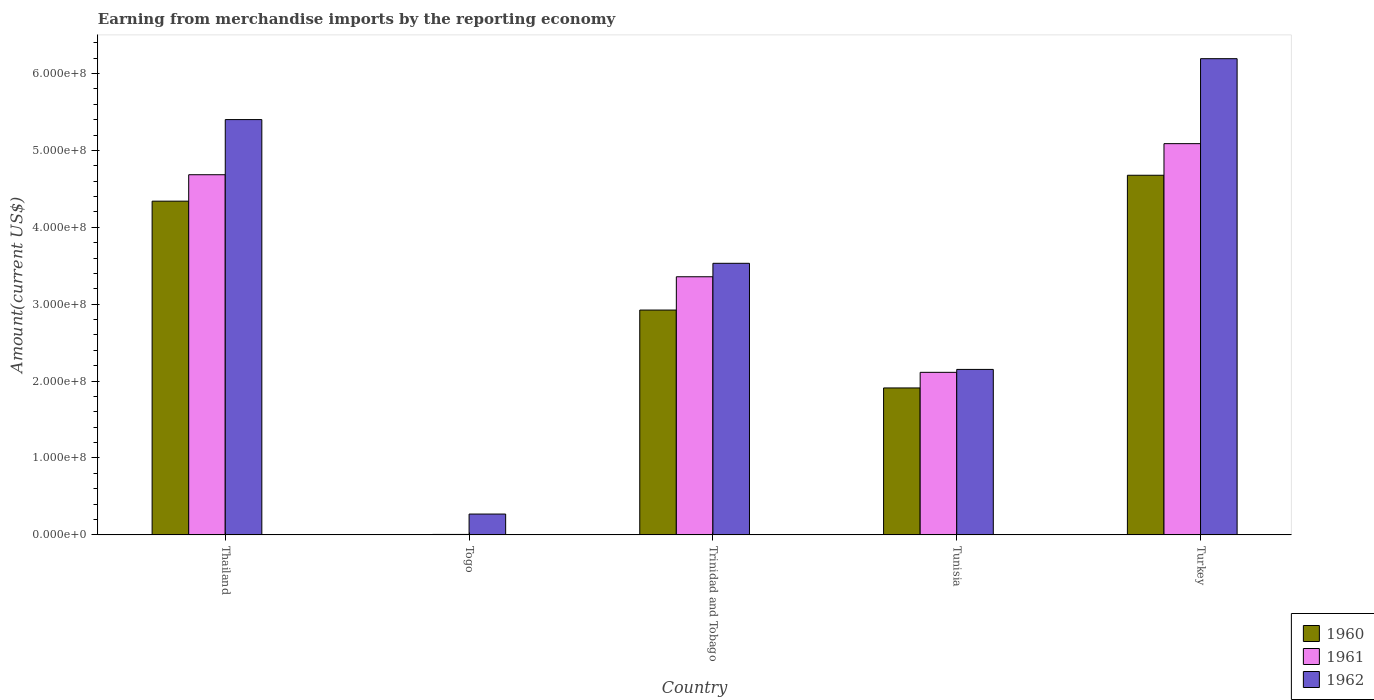How many different coloured bars are there?
Ensure brevity in your answer.  3. Are the number of bars on each tick of the X-axis equal?
Your answer should be compact. Yes. What is the label of the 1st group of bars from the left?
Your response must be concise. Thailand. In how many cases, is the number of bars for a given country not equal to the number of legend labels?
Offer a terse response. 0. What is the amount earned from merchandise imports in 1960 in Tunisia?
Your answer should be compact. 1.91e+08. Across all countries, what is the maximum amount earned from merchandise imports in 1961?
Ensure brevity in your answer.  5.09e+08. Across all countries, what is the minimum amount earned from merchandise imports in 1962?
Your answer should be compact. 2.71e+07. In which country was the amount earned from merchandise imports in 1962 minimum?
Ensure brevity in your answer.  Togo. What is the total amount earned from merchandise imports in 1961 in the graph?
Give a very brief answer. 1.52e+09. What is the difference between the amount earned from merchandise imports in 1960 in Thailand and that in Turkey?
Offer a very short reply. -3.37e+07. What is the difference between the amount earned from merchandise imports in 1960 in Togo and the amount earned from merchandise imports in 1962 in Thailand?
Your answer should be compact. -5.40e+08. What is the average amount earned from merchandise imports in 1961 per country?
Make the answer very short. 3.05e+08. What is the difference between the amount earned from merchandise imports of/in 1961 and amount earned from merchandise imports of/in 1962 in Togo?
Your response must be concise. -2.65e+07. What is the ratio of the amount earned from merchandise imports in 1962 in Thailand to that in Togo?
Provide a succinct answer. 19.93. What is the difference between the highest and the second highest amount earned from merchandise imports in 1960?
Your response must be concise. 1.75e+08. What is the difference between the highest and the lowest amount earned from merchandise imports in 1961?
Offer a very short reply. 5.08e+08. How many countries are there in the graph?
Ensure brevity in your answer.  5. What is the difference between two consecutive major ticks on the Y-axis?
Offer a very short reply. 1.00e+08. Does the graph contain any zero values?
Ensure brevity in your answer.  No. How many legend labels are there?
Offer a terse response. 3. How are the legend labels stacked?
Offer a terse response. Vertical. What is the title of the graph?
Your response must be concise. Earning from merchandise imports by the reporting economy. What is the label or title of the X-axis?
Your answer should be compact. Country. What is the label or title of the Y-axis?
Your answer should be very brief. Amount(current US$). What is the Amount(current US$) of 1960 in Thailand?
Offer a terse response. 4.34e+08. What is the Amount(current US$) of 1961 in Thailand?
Your response must be concise. 4.68e+08. What is the Amount(current US$) in 1962 in Thailand?
Ensure brevity in your answer.  5.40e+08. What is the Amount(current US$) in 1961 in Togo?
Ensure brevity in your answer.  6.00e+05. What is the Amount(current US$) in 1962 in Togo?
Make the answer very short. 2.71e+07. What is the Amount(current US$) of 1960 in Trinidad and Tobago?
Give a very brief answer. 2.92e+08. What is the Amount(current US$) of 1961 in Trinidad and Tobago?
Give a very brief answer. 3.36e+08. What is the Amount(current US$) in 1962 in Trinidad and Tobago?
Provide a short and direct response. 3.53e+08. What is the Amount(current US$) of 1960 in Tunisia?
Ensure brevity in your answer.  1.91e+08. What is the Amount(current US$) in 1961 in Tunisia?
Keep it short and to the point. 2.11e+08. What is the Amount(current US$) of 1962 in Tunisia?
Ensure brevity in your answer.  2.15e+08. What is the Amount(current US$) in 1960 in Turkey?
Offer a terse response. 4.68e+08. What is the Amount(current US$) of 1961 in Turkey?
Keep it short and to the point. 5.09e+08. What is the Amount(current US$) of 1962 in Turkey?
Provide a short and direct response. 6.19e+08. Across all countries, what is the maximum Amount(current US$) in 1960?
Your answer should be very brief. 4.68e+08. Across all countries, what is the maximum Amount(current US$) of 1961?
Make the answer very short. 5.09e+08. Across all countries, what is the maximum Amount(current US$) in 1962?
Offer a terse response. 6.19e+08. Across all countries, what is the minimum Amount(current US$) of 1960?
Make the answer very short. 4.00e+05. Across all countries, what is the minimum Amount(current US$) in 1961?
Ensure brevity in your answer.  6.00e+05. Across all countries, what is the minimum Amount(current US$) of 1962?
Provide a succinct answer. 2.71e+07. What is the total Amount(current US$) of 1960 in the graph?
Your answer should be compact. 1.39e+09. What is the total Amount(current US$) of 1961 in the graph?
Ensure brevity in your answer.  1.52e+09. What is the total Amount(current US$) of 1962 in the graph?
Ensure brevity in your answer.  1.75e+09. What is the difference between the Amount(current US$) in 1960 in Thailand and that in Togo?
Your answer should be compact. 4.34e+08. What is the difference between the Amount(current US$) of 1961 in Thailand and that in Togo?
Your answer should be very brief. 4.68e+08. What is the difference between the Amount(current US$) in 1962 in Thailand and that in Togo?
Your answer should be compact. 5.13e+08. What is the difference between the Amount(current US$) of 1960 in Thailand and that in Trinidad and Tobago?
Your response must be concise. 1.42e+08. What is the difference between the Amount(current US$) in 1961 in Thailand and that in Trinidad and Tobago?
Your answer should be compact. 1.33e+08. What is the difference between the Amount(current US$) of 1962 in Thailand and that in Trinidad and Tobago?
Offer a very short reply. 1.87e+08. What is the difference between the Amount(current US$) in 1960 in Thailand and that in Tunisia?
Your response must be concise. 2.43e+08. What is the difference between the Amount(current US$) of 1961 in Thailand and that in Tunisia?
Your response must be concise. 2.57e+08. What is the difference between the Amount(current US$) of 1962 in Thailand and that in Tunisia?
Your answer should be very brief. 3.25e+08. What is the difference between the Amount(current US$) in 1960 in Thailand and that in Turkey?
Make the answer very short. -3.37e+07. What is the difference between the Amount(current US$) of 1961 in Thailand and that in Turkey?
Give a very brief answer. -4.04e+07. What is the difference between the Amount(current US$) in 1962 in Thailand and that in Turkey?
Your response must be concise. -7.92e+07. What is the difference between the Amount(current US$) of 1960 in Togo and that in Trinidad and Tobago?
Provide a short and direct response. -2.92e+08. What is the difference between the Amount(current US$) in 1961 in Togo and that in Trinidad and Tobago?
Provide a succinct answer. -3.35e+08. What is the difference between the Amount(current US$) in 1962 in Togo and that in Trinidad and Tobago?
Provide a short and direct response. -3.26e+08. What is the difference between the Amount(current US$) of 1960 in Togo and that in Tunisia?
Offer a terse response. -1.91e+08. What is the difference between the Amount(current US$) in 1961 in Togo and that in Tunisia?
Your answer should be very brief. -2.11e+08. What is the difference between the Amount(current US$) in 1962 in Togo and that in Tunisia?
Your answer should be compact. -1.88e+08. What is the difference between the Amount(current US$) of 1960 in Togo and that in Turkey?
Offer a terse response. -4.67e+08. What is the difference between the Amount(current US$) in 1961 in Togo and that in Turkey?
Ensure brevity in your answer.  -5.08e+08. What is the difference between the Amount(current US$) in 1962 in Togo and that in Turkey?
Provide a succinct answer. -5.92e+08. What is the difference between the Amount(current US$) of 1960 in Trinidad and Tobago and that in Tunisia?
Your answer should be compact. 1.01e+08. What is the difference between the Amount(current US$) in 1961 in Trinidad and Tobago and that in Tunisia?
Keep it short and to the point. 1.24e+08. What is the difference between the Amount(current US$) in 1962 in Trinidad and Tobago and that in Tunisia?
Your answer should be compact. 1.38e+08. What is the difference between the Amount(current US$) of 1960 in Trinidad and Tobago and that in Turkey?
Ensure brevity in your answer.  -1.75e+08. What is the difference between the Amount(current US$) in 1961 in Trinidad and Tobago and that in Turkey?
Your answer should be very brief. -1.73e+08. What is the difference between the Amount(current US$) of 1962 in Trinidad and Tobago and that in Turkey?
Provide a short and direct response. -2.66e+08. What is the difference between the Amount(current US$) in 1960 in Tunisia and that in Turkey?
Offer a very short reply. -2.77e+08. What is the difference between the Amount(current US$) in 1961 in Tunisia and that in Turkey?
Provide a succinct answer. -2.97e+08. What is the difference between the Amount(current US$) in 1962 in Tunisia and that in Turkey?
Provide a succinct answer. -4.04e+08. What is the difference between the Amount(current US$) in 1960 in Thailand and the Amount(current US$) in 1961 in Togo?
Provide a succinct answer. 4.33e+08. What is the difference between the Amount(current US$) in 1960 in Thailand and the Amount(current US$) in 1962 in Togo?
Offer a very short reply. 4.07e+08. What is the difference between the Amount(current US$) of 1961 in Thailand and the Amount(current US$) of 1962 in Togo?
Your response must be concise. 4.41e+08. What is the difference between the Amount(current US$) of 1960 in Thailand and the Amount(current US$) of 1961 in Trinidad and Tobago?
Your answer should be very brief. 9.83e+07. What is the difference between the Amount(current US$) in 1960 in Thailand and the Amount(current US$) in 1962 in Trinidad and Tobago?
Offer a very short reply. 8.08e+07. What is the difference between the Amount(current US$) of 1961 in Thailand and the Amount(current US$) of 1962 in Trinidad and Tobago?
Offer a very short reply. 1.15e+08. What is the difference between the Amount(current US$) of 1960 in Thailand and the Amount(current US$) of 1961 in Tunisia?
Offer a very short reply. 2.23e+08. What is the difference between the Amount(current US$) in 1960 in Thailand and the Amount(current US$) in 1962 in Tunisia?
Offer a very short reply. 2.19e+08. What is the difference between the Amount(current US$) of 1961 in Thailand and the Amount(current US$) of 1962 in Tunisia?
Give a very brief answer. 2.53e+08. What is the difference between the Amount(current US$) of 1960 in Thailand and the Amount(current US$) of 1961 in Turkey?
Your answer should be compact. -7.48e+07. What is the difference between the Amount(current US$) of 1960 in Thailand and the Amount(current US$) of 1962 in Turkey?
Keep it short and to the point. -1.85e+08. What is the difference between the Amount(current US$) in 1961 in Thailand and the Amount(current US$) in 1962 in Turkey?
Your response must be concise. -1.51e+08. What is the difference between the Amount(current US$) in 1960 in Togo and the Amount(current US$) in 1961 in Trinidad and Tobago?
Offer a terse response. -3.35e+08. What is the difference between the Amount(current US$) in 1960 in Togo and the Amount(current US$) in 1962 in Trinidad and Tobago?
Give a very brief answer. -3.53e+08. What is the difference between the Amount(current US$) of 1961 in Togo and the Amount(current US$) of 1962 in Trinidad and Tobago?
Keep it short and to the point. -3.53e+08. What is the difference between the Amount(current US$) in 1960 in Togo and the Amount(current US$) in 1961 in Tunisia?
Offer a terse response. -2.11e+08. What is the difference between the Amount(current US$) in 1960 in Togo and the Amount(current US$) in 1962 in Tunisia?
Offer a terse response. -2.15e+08. What is the difference between the Amount(current US$) of 1961 in Togo and the Amount(current US$) of 1962 in Tunisia?
Keep it short and to the point. -2.15e+08. What is the difference between the Amount(current US$) in 1960 in Togo and the Amount(current US$) in 1961 in Turkey?
Give a very brief answer. -5.08e+08. What is the difference between the Amount(current US$) of 1960 in Togo and the Amount(current US$) of 1962 in Turkey?
Keep it short and to the point. -6.19e+08. What is the difference between the Amount(current US$) of 1961 in Togo and the Amount(current US$) of 1962 in Turkey?
Your answer should be very brief. -6.19e+08. What is the difference between the Amount(current US$) of 1960 in Trinidad and Tobago and the Amount(current US$) of 1961 in Tunisia?
Ensure brevity in your answer.  8.10e+07. What is the difference between the Amount(current US$) of 1960 in Trinidad and Tobago and the Amount(current US$) of 1962 in Tunisia?
Give a very brief answer. 7.72e+07. What is the difference between the Amount(current US$) of 1961 in Trinidad and Tobago and the Amount(current US$) of 1962 in Tunisia?
Offer a very short reply. 1.20e+08. What is the difference between the Amount(current US$) of 1960 in Trinidad and Tobago and the Amount(current US$) of 1961 in Turkey?
Your response must be concise. -2.16e+08. What is the difference between the Amount(current US$) of 1960 in Trinidad and Tobago and the Amount(current US$) of 1962 in Turkey?
Provide a short and direct response. -3.27e+08. What is the difference between the Amount(current US$) of 1961 in Trinidad and Tobago and the Amount(current US$) of 1962 in Turkey?
Make the answer very short. -2.84e+08. What is the difference between the Amount(current US$) of 1960 in Tunisia and the Amount(current US$) of 1961 in Turkey?
Offer a terse response. -3.18e+08. What is the difference between the Amount(current US$) of 1960 in Tunisia and the Amount(current US$) of 1962 in Turkey?
Ensure brevity in your answer.  -4.28e+08. What is the difference between the Amount(current US$) in 1961 in Tunisia and the Amount(current US$) in 1962 in Turkey?
Your answer should be compact. -4.08e+08. What is the average Amount(current US$) in 1960 per country?
Ensure brevity in your answer.  2.77e+08. What is the average Amount(current US$) of 1961 per country?
Keep it short and to the point. 3.05e+08. What is the average Amount(current US$) of 1962 per country?
Give a very brief answer. 3.51e+08. What is the difference between the Amount(current US$) of 1960 and Amount(current US$) of 1961 in Thailand?
Ensure brevity in your answer.  -3.44e+07. What is the difference between the Amount(current US$) of 1960 and Amount(current US$) of 1962 in Thailand?
Your answer should be very brief. -1.06e+08. What is the difference between the Amount(current US$) of 1961 and Amount(current US$) of 1962 in Thailand?
Provide a short and direct response. -7.17e+07. What is the difference between the Amount(current US$) in 1960 and Amount(current US$) in 1961 in Togo?
Ensure brevity in your answer.  -2.00e+05. What is the difference between the Amount(current US$) in 1960 and Amount(current US$) in 1962 in Togo?
Provide a short and direct response. -2.67e+07. What is the difference between the Amount(current US$) of 1961 and Amount(current US$) of 1962 in Togo?
Provide a succinct answer. -2.65e+07. What is the difference between the Amount(current US$) of 1960 and Amount(current US$) of 1961 in Trinidad and Tobago?
Your response must be concise. -4.33e+07. What is the difference between the Amount(current US$) of 1960 and Amount(current US$) of 1962 in Trinidad and Tobago?
Keep it short and to the point. -6.08e+07. What is the difference between the Amount(current US$) in 1961 and Amount(current US$) in 1962 in Trinidad and Tobago?
Give a very brief answer. -1.75e+07. What is the difference between the Amount(current US$) in 1960 and Amount(current US$) in 1961 in Tunisia?
Offer a terse response. -2.03e+07. What is the difference between the Amount(current US$) in 1960 and Amount(current US$) in 1962 in Tunisia?
Give a very brief answer. -2.41e+07. What is the difference between the Amount(current US$) in 1961 and Amount(current US$) in 1962 in Tunisia?
Offer a very short reply. -3.80e+06. What is the difference between the Amount(current US$) in 1960 and Amount(current US$) in 1961 in Turkey?
Provide a short and direct response. -4.11e+07. What is the difference between the Amount(current US$) in 1960 and Amount(current US$) in 1962 in Turkey?
Your response must be concise. -1.52e+08. What is the difference between the Amount(current US$) in 1961 and Amount(current US$) in 1962 in Turkey?
Ensure brevity in your answer.  -1.10e+08. What is the ratio of the Amount(current US$) of 1960 in Thailand to that in Togo?
Your answer should be very brief. 1085. What is the ratio of the Amount(current US$) of 1961 in Thailand to that in Togo?
Ensure brevity in your answer.  780.67. What is the ratio of the Amount(current US$) of 1962 in Thailand to that in Togo?
Offer a terse response. 19.93. What is the ratio of the Amount(current US$) of 1960 in Thailand to that in Trinidad and Tobago?
Keep it short and to the point. 1.48. What is the ratio of the Amount(current US$) of 1961 in Thailand to that in Trinidad and Tobago?
Keep it short and to the point. 1.4. What is the ratio of the Amount(current US$) of 1962 in Thailand to that in Trinidad and Tobago?
Make the answer very short. 1.53. What is the ratio of the Amount(current US$) in 1960 in Thailand to that in Tunisia?
Offer a terse response. 2.27. What is the ratio of the Amount(current US$) of 1961 in Thailand to that in Tunisia?
Give a very brief answer. 2.22. What is the ratio of the Amount(current US$) of 1962 in Thailand to that in Tunisia?
Keep it short and to the point. 2.51. What is the ratio of the Amount(current US$) of 1960 in Thailand to that in Turkey?
Offer a very short reply. 0.93. What is the ratio of the Amount(current US$) in 1961 in Thailand to that in Turkey?
Offer a terse response. 0.92. What is the ratio of the Amount(current US$) of 1962 in Thailand to that in Turkey?
Keep it short and to the point. 0.87. What is the ratio of the Amount(current US$) in 1960 in Togo to that in Trinidad and Tobago?
Your answer should be very brief. 0. What is the ratio of the Amount(current US$) of 1961 in Togo to that in Trinidad and Tobago?
Ensure brevity in your answer.  0. What is the ratio of the Amount(current US$) of 1962 in Togo to that in Trinidad and Tobago?
Offer a very short reply. 0.08. What is the ratio of the Amount(current US$) of 1960 in Togo to that in Tunisia?
Provide a short and direct response. 0. What is the ratio of the Amount(current US$) in 1961 in Togo to that in Tunisia?
Offer a terse response. 0. What is the ratio of the Amount(current US$) of 1962 in Togo to that in Tunisia?
Your response must be concise. 0.13. What is the ratio of the Amount(current US$) in 1960 in Togo to that in Turkey?
Give a very brief answer. 0. What is the ratio of the Amount(current US$) in 1961 in Togo to that in Turkey?
Your response must be concise. 0. What is the ratio of the Amount(current US$) of 1962 in Togo to that in Turkey?
Provide a succinct answer. 0.04. What is the ratio of the Amount(current US$) of 1960 in Trinidad and Tobago to that in Tunisia?
Give a very brief answer. 1.53. What is the ratio of the Amount(current US$) in 1961 in Trinidad and Tobago to that in Tunisia?
Give a very brief answer. 1.59. What is the ratio of the Amount(current US$) of 1962 in Trinidad and Tobago to that in Tunisia?
Your answer should be compact. 1.64. What is the ratio of the Amount(current US$) of 1960 in Trinidad and Tobago to that in Turkey?
Ensure brevity in your answer.  0.63. What is the ratio of the Amount(current US$) in 1961 in Trinidad and Tobago to that in Turkey?
Keep it short and to the point. 0.66. What is the ratio of the Amount(current US$) in 1962 in Trinidad and Tobago to that in Turkey?
Your response must be concise. 0.57. What is the ratio of the Amount(current US$) in 1960 in Tunisia to that in Turkey?
Offer a terse response. 0.41. What is the ratio of the Amount(current US$) of 1961 in Tunisia to that in Turkey?
Make the answer very short. 0.42. What is the ratio of the Amount(current US$) in 1962 in Tunisia to that in Turkey?
Make the answer very short. 0.35. What is the difference between the highest and the second highest Amount(current US$) of 1960?
Give a very brief answer. 3.37e+07. What is the difference between the highest and the second highest Amount(current US$) in 1961?
Keep it short and to the point. 4.04e+07. What is the difference between the highest and the second highest Amount(current US$) of 1962?
Offer a terse response. 7.92e+07. What is the difference between the highest and the lowest Amount(current US$) of 1960?
Make the answer very short. 4.67e+08. What is the difference between the highest and the lowest Amount(current US$) of 1961?
Make the answer very short. 5.08e+08. What is the difference between the highest and the lowest Amount(current US$) of 1962?
Make the answer very short. 5.92e+08. 